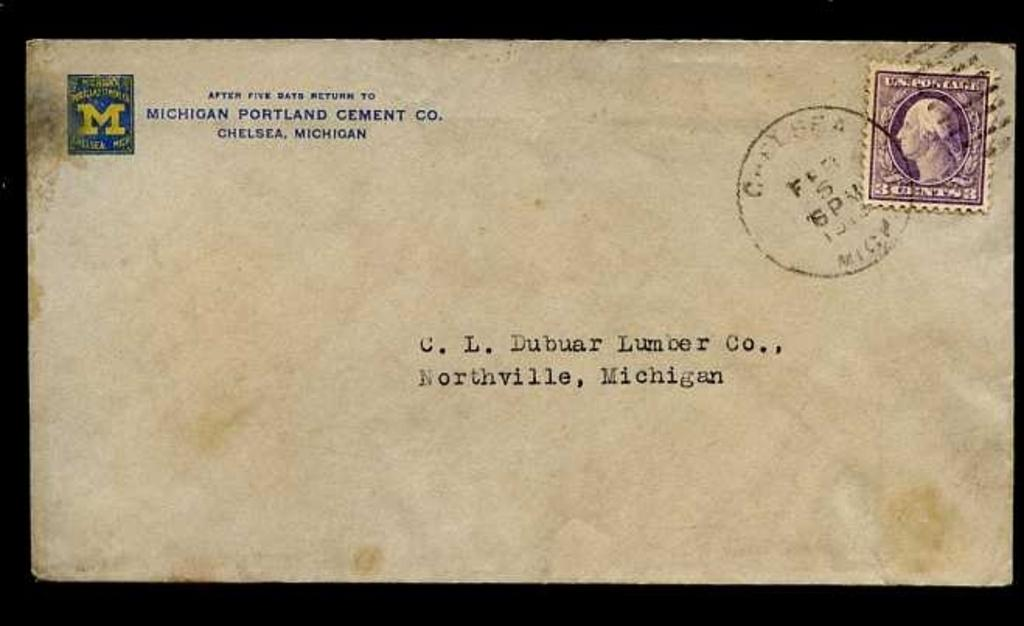<image>
Share a concise interpretation of the image provided. an envelope addressed to C.L. Dubuar Lumber of Northville, Michigan 